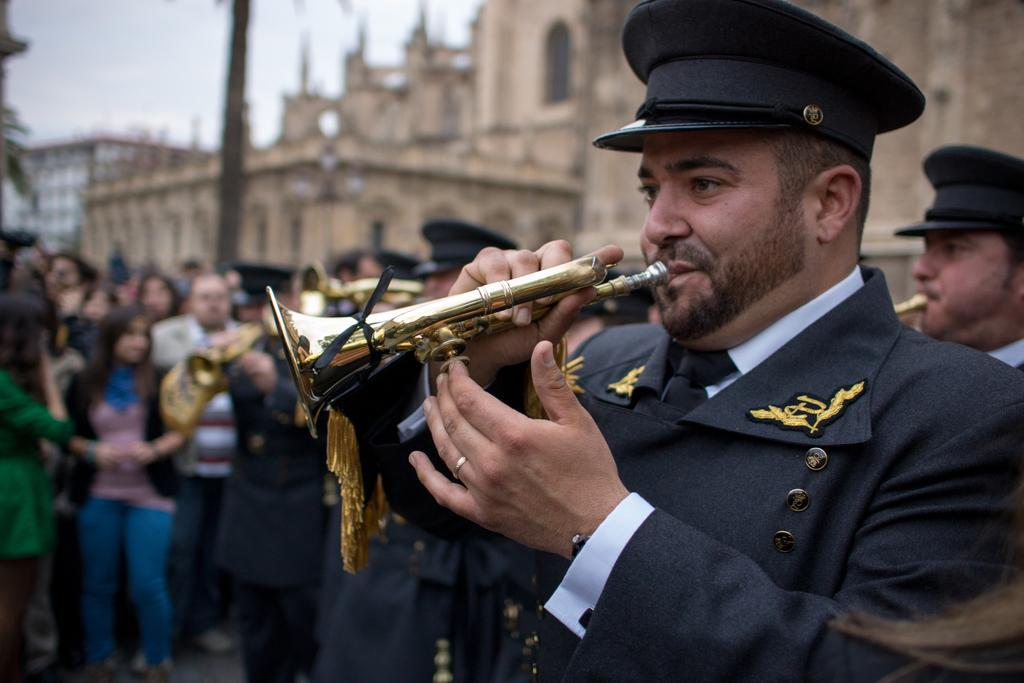What are the people in the image doing? The people in the image are playing brass instruments. Can you describe the other groups of people in the image? There are groups of people behind the musicians. What can be seen in the background of the image? Buildings and the sky are visible in the background. What type of punishment is being administered to the musicians in the image? There is no punishment being administered to the musicians in the image; they are playing brass instruments. What is the range of the silver instruments being played in the image? There are no silver instruments present in the image; the musicians are playing brass instruments. 